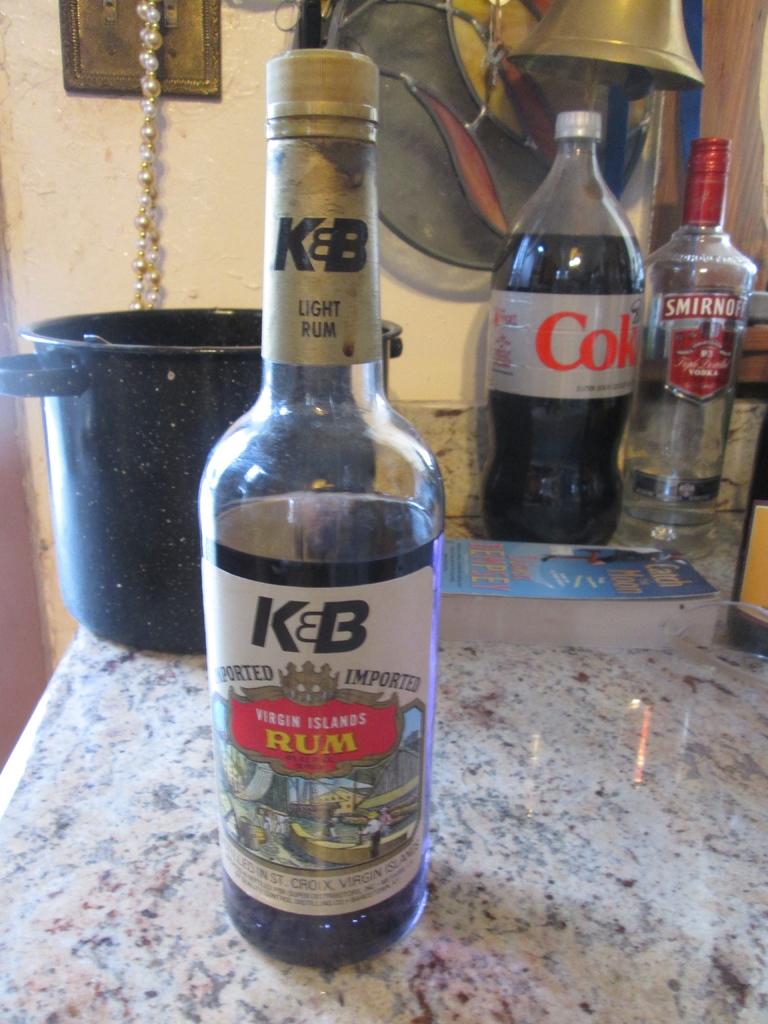What brand of vodka is next to the coke bottle in the distance?
Make the answer very short. Smirnoff. What kind of liquor is in the closest bottle?
Your answer should be very brief. Rum. 